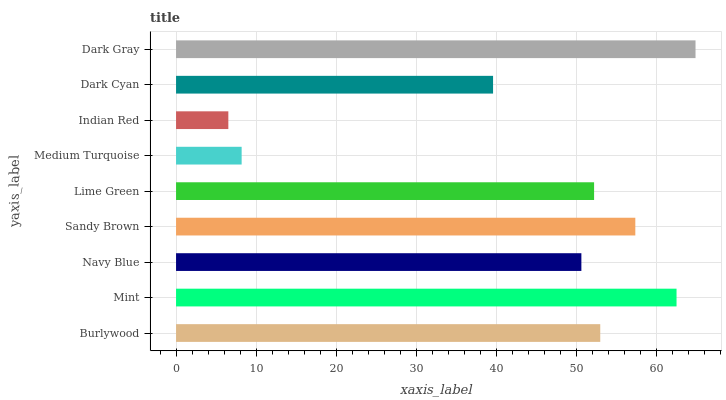Is Indian Red the minimum?
Answer yes or no. Yes. Is Dark Gray the maximum?
Answer yes or no. Yes. Is Mint the minimum?
Answer yes or no. No. Is Mint the maximum?
Answer yes or no. No. Is Mint greater than Burlywood?
Answer yes or no. Yes. Is Burlywood less than Mint?
Answer yes or no. Yes. Is Burlywood greater than Mint?
Answer yes or no. No. Is Mint less than Burlywood?
Answer yes or no. No. Is Lime Green the high median?
Answer yes or no. Yes. Is Lime Green the low median?
Answer yes or no. Yes. Is Sandy Brown the high median?
Answer yes or no. No. Is Mint the low median?
Answer yes or no. No. 